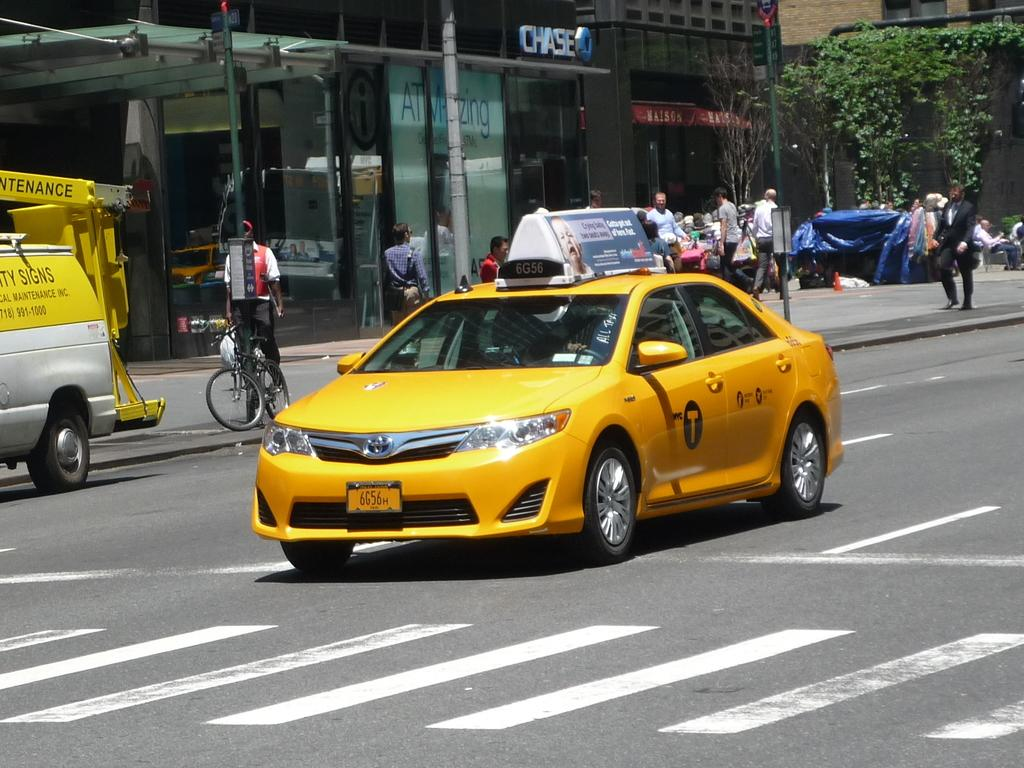<image>
Present a compact description of the photo's key features. A taxi cab is driving down a road, just past a Chase bank. 